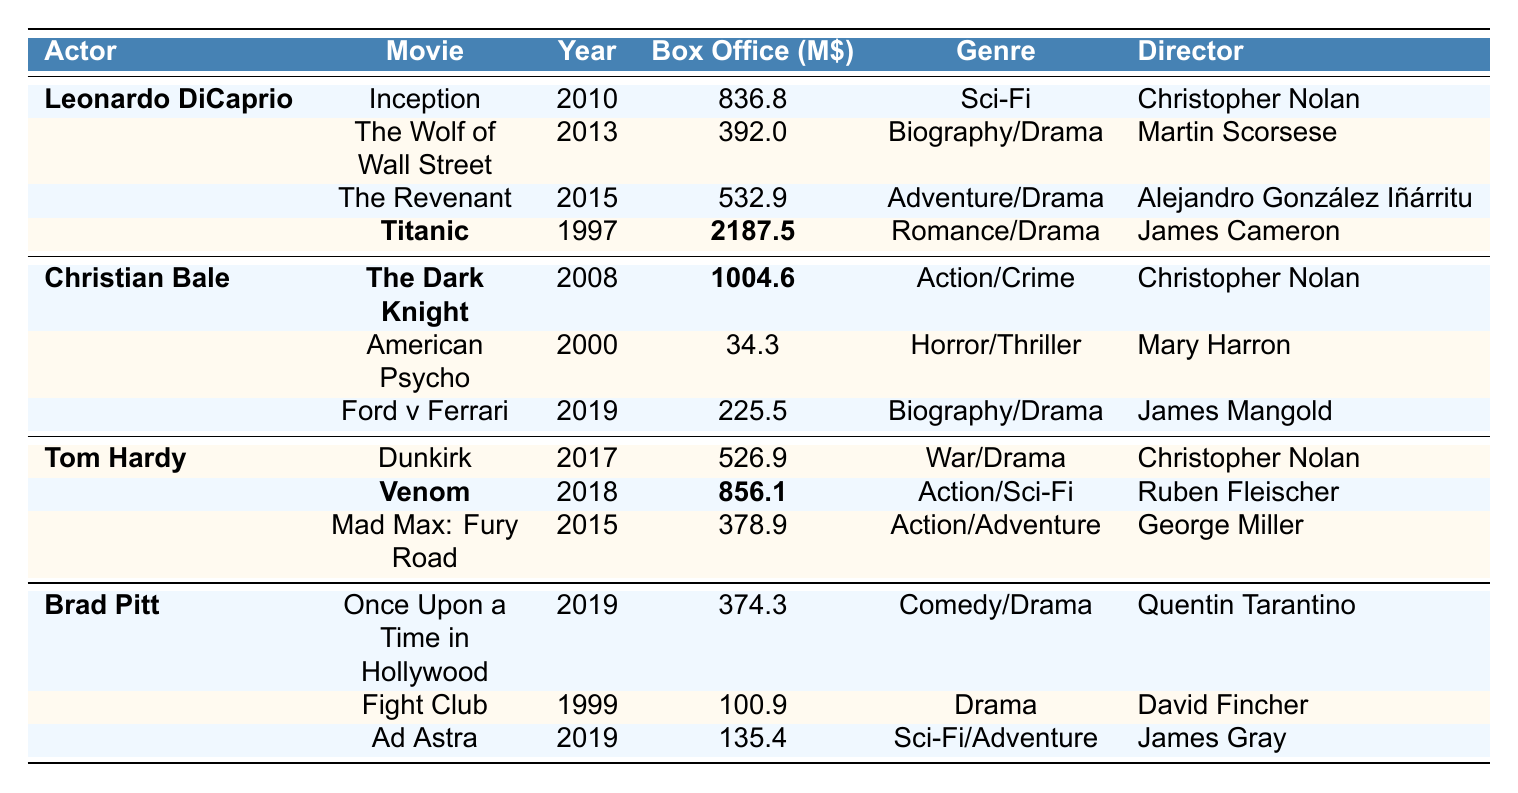What is the highest box office gross among the movies listed? The table reveals that "Titanic," released in 1997, has a box office gross of 2187.5 million dollars, which is greater than all other entries.
Answer: 2187.5 million dollars Which actor appears in the movie with the lowest box office gross? The film "American Psycho," featuring Christian Bale, shows the lowest box office figure at 34.3 million dollars, the lowest in the table.
Answer: Christian Bale What is the total box office gross for movies featuring Tom Hardy? The movies featuring Tom Hardy are "Dunkirk" (526.9), "Venom" (856.1), and "Mad Max: Fury Road" (378.9). Adding these gives 526.9 + 856.1 + 378.9 = 1761.9 million dollars.
Answer: 1761.9 million dollars Which movie directed by Christopher Nolan has the highest box office gross? The films by Christopher Nolan in the table are "Inception" (836.8) and "The Dark Knight" (1004.6). Comparing these, "The Dark Knight" has the higher gross of 1004.6 million dollars.
Answer: The Dark Knight Is "Once Upon a Time in Hollywood" the only movie featuring Brad Pitt released in 2019? The table shows three movies with Brad Pitt, and two of them, "Ad Astra" and "Once Upon a Time in Hollywood," were released in 2019. Therefore, it is not the only movie from that year featuring him.
Answer: No What is the average box office gross of all movies featuring Leonardo DiCaprio? The movies are "Inception" (836.8), "The Wolf of Wall Street" (392.0), "The Revenant" (532.9), and "Titanic" (2187.5). The total gross is 836.8 + 392.0 + 532.9 + 2187.5 = 3949.2 million dollars. There are 4 movies so the average is 3949.2 / 4 = 987.3 million dollars.
Answer: 987.3 million dollars Which director appears most frequently in this box office table? After examining the table, Christopher Nolan appears as the director for three movies: "Inception," "The Dark Knight," and "Dunkirk." This is more than any other director in the list.
Answer: Christopher Nolan What percentage of box office gross did "Titanic" contribute to the total gross of all movies in the table? The total box office gross for all movies is 3949.2 million dollars. "Titanic" contributed 2187.5 million dollars. The percentage is (2187.5 / 3949.2) * 100 ≈ 55.4%.
Answer: 55.4% Which actor has the highest average box office gross per film? Calculating the averages: Leonardo DiCaprio's movies total 3949.2 (4 films), Christian Bale's total is 1264.4 (3 films), Tom Hardy's total is 1761.9 (3 films), and Brad Pitt's total is 610.6 (3 films). The averages are: DiCaprio 987.3, Bale 421.5, Hardy 587.3, Pitt 203.5. Leonardo DiCaprio has the highest average of 987.3 million dollars.
Answer: Leonardo DiCaprio 